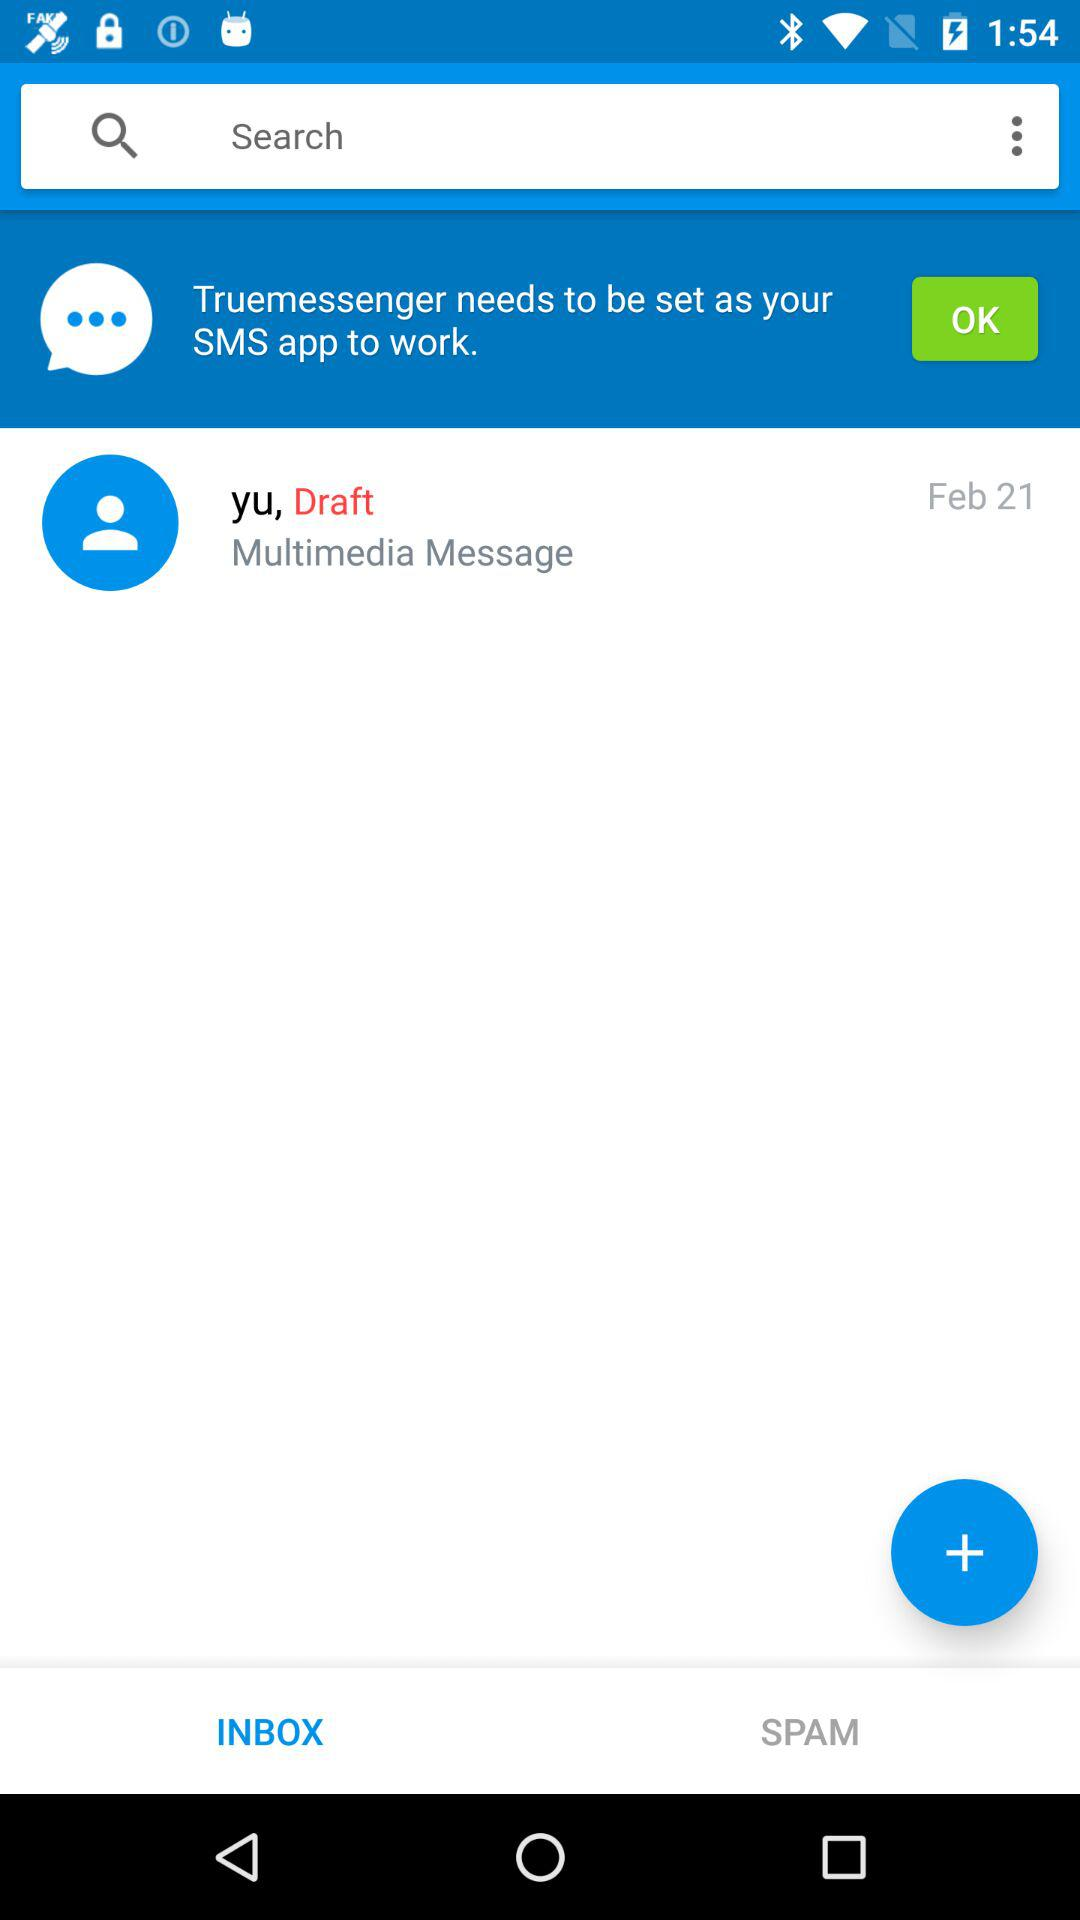What is the date of the drafted message? The date of the drafted message is February 21. 